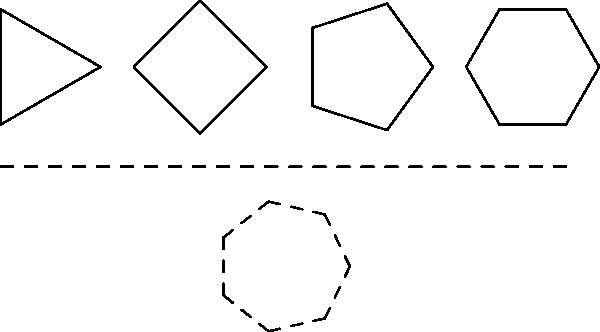In this sequence of shapes, each figure has one more side than the previous one. What shape should come next to continue the pattern? To solve this problem, let's analyze the pattern step-by-step:

1. The first shape is a triangle with 3 sides.
2. The second shape is a square with 4 sides.
3. The third shape is a pentagon with 5 sides.
4. The fourth shape is a hexagon with 6 sides.

We can observe that each subsequent shape has one more side than the previous one. This forms an arithmetic sequence with a common difference of 1.

To determine the next shape in the sequence:

5. We add 1 to the number of sides of the last shape (hexagon):
   $6 + 1 = 7$

Therefore, the next shape in the sequence should have 7 sides.

A shape with 7 sides is called a heptagon.

This pattern of increasing sides could be particularly interesting for a sweepstakes enthusiast, as it resembles the increasing complexity or stages one might encounter in contest rules or promotional games.
Answer: Heptagon 